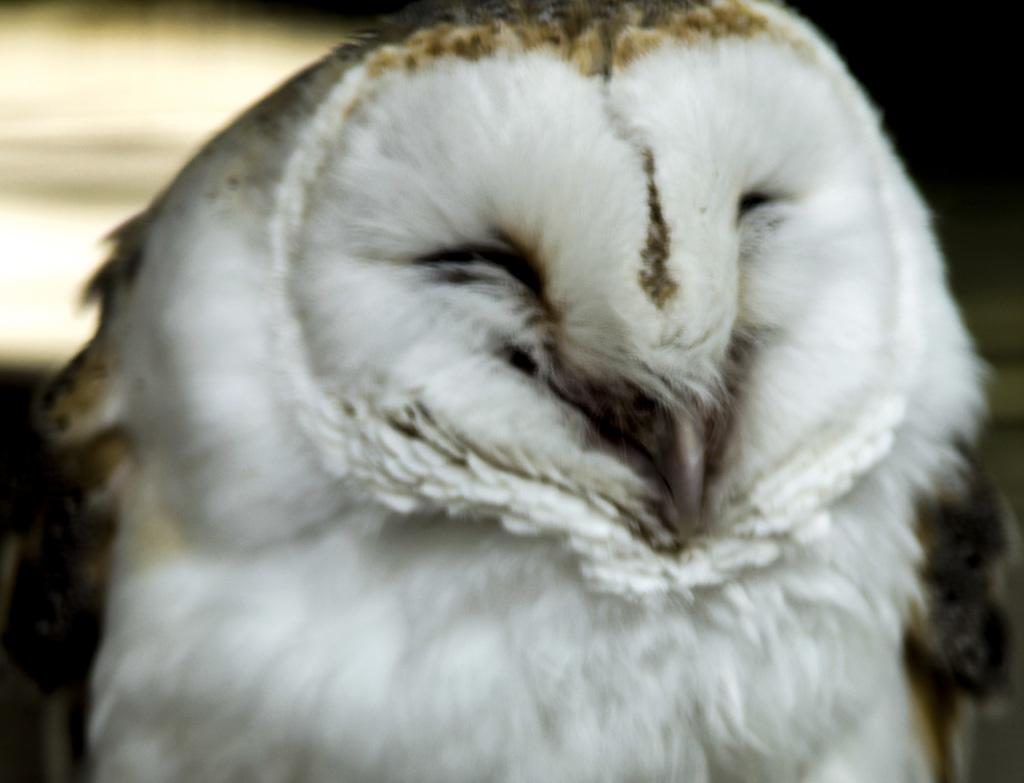What type of animal is in the image? There is a bird in the image. Can you describe the background of the image? The background of the image is blurred. How many cows are visible in the image? There are no cows present in the image; it features a bird. What type of cave can be seen in the background of the image? There is no cave present in the image; the background is blurred. 